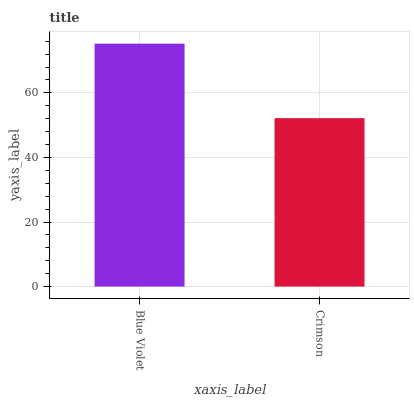Is Crimson the maximum?
Answer yes or no. No. Is Blue Violet greater than Crimson?
Answer yes or no. Yes. Is Crimson less than Blue Violet?
Answer yes or no. Yes. Is Crimson greater than Blue Violet?
Answer yes or no. No. Is Blue Violet less than Crimson?
Answer yes or no. No. Is Blue Violet the high median?
Answer yes or no. Yes. Is Crimson the low median?
Answer yes or no. Yes. Is Crimson the high median?
Answer yes or no. No. Is Blue Violet the low median?
Answer yes or no. No. 